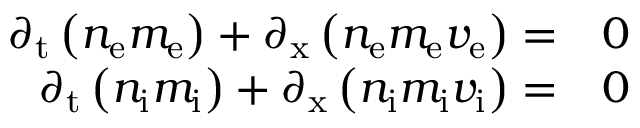<formula> <loc_0><loc_0><loc_500><loc_500>\begin{array} { r l } { \partial _ { t } \left ( n _ { e } m _ { e } \right ) + \partial _ { x } \left ( n _ { e } m _ { e } v _ { e } \right ) = } & 0 } \\ { \partial _ { t } \left ( n _ { i } m _ { i } \right ) + \partial _ { x } \left ( n _ { i } m _ { i } v _ { i } \right ) = } & 0 } \end{array}</formula> 